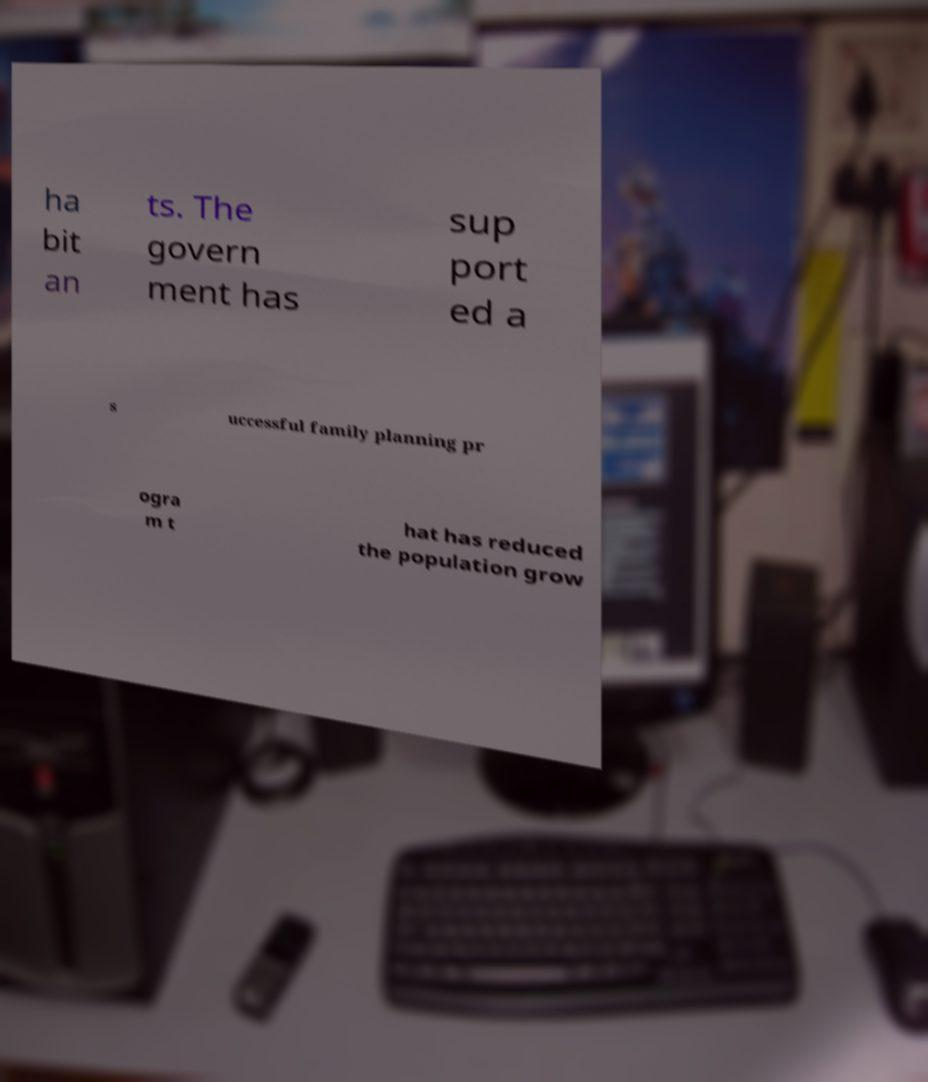There's text embedded in this image that I need extracted. Can you transcribe it verbatim? ha bit an ts. The govern ment has sup port ed a s uccessful family planning pr ogra m t hat has reduced the population grow 